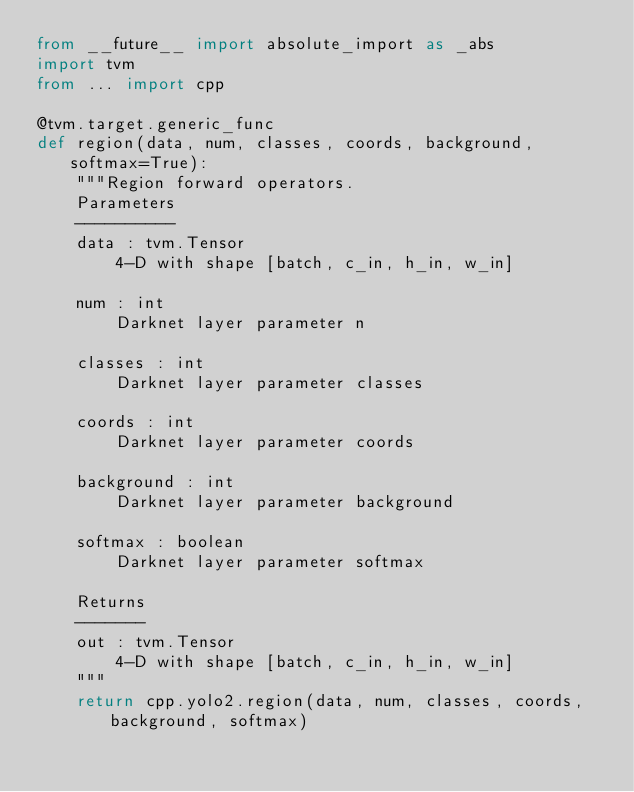<code> <loc_0><loc_0><loc_500><loc_500><_Python_>from __future__ import absolute_import as _abs
import tvm
from ... import cpp

@tvm.target.generic_func
def region(data, num, classes, coords, background, softmax=True):
    """Region forward operators.
    Parameters
    ----------
    data : tvm.Tensor
        4-D with shape [batch, c_in, h_in, w_in]

    num : int
        Darknet layer parameter n

    classes : int
        Darknet layer parameter classes

    coords : int
        Darknet layer parameter coords

    background : int
        Darknet layer parameter background

    softmax : boolean
        Darknet layer parameter softmax

    Returns
    -------
    out : tvm.Tensor
        4-D with shape [batch, c_in, h_in, w_in]
    """
    return cpp.yolo2.region(data, num, classes, coords, background, softmax)
</code> 